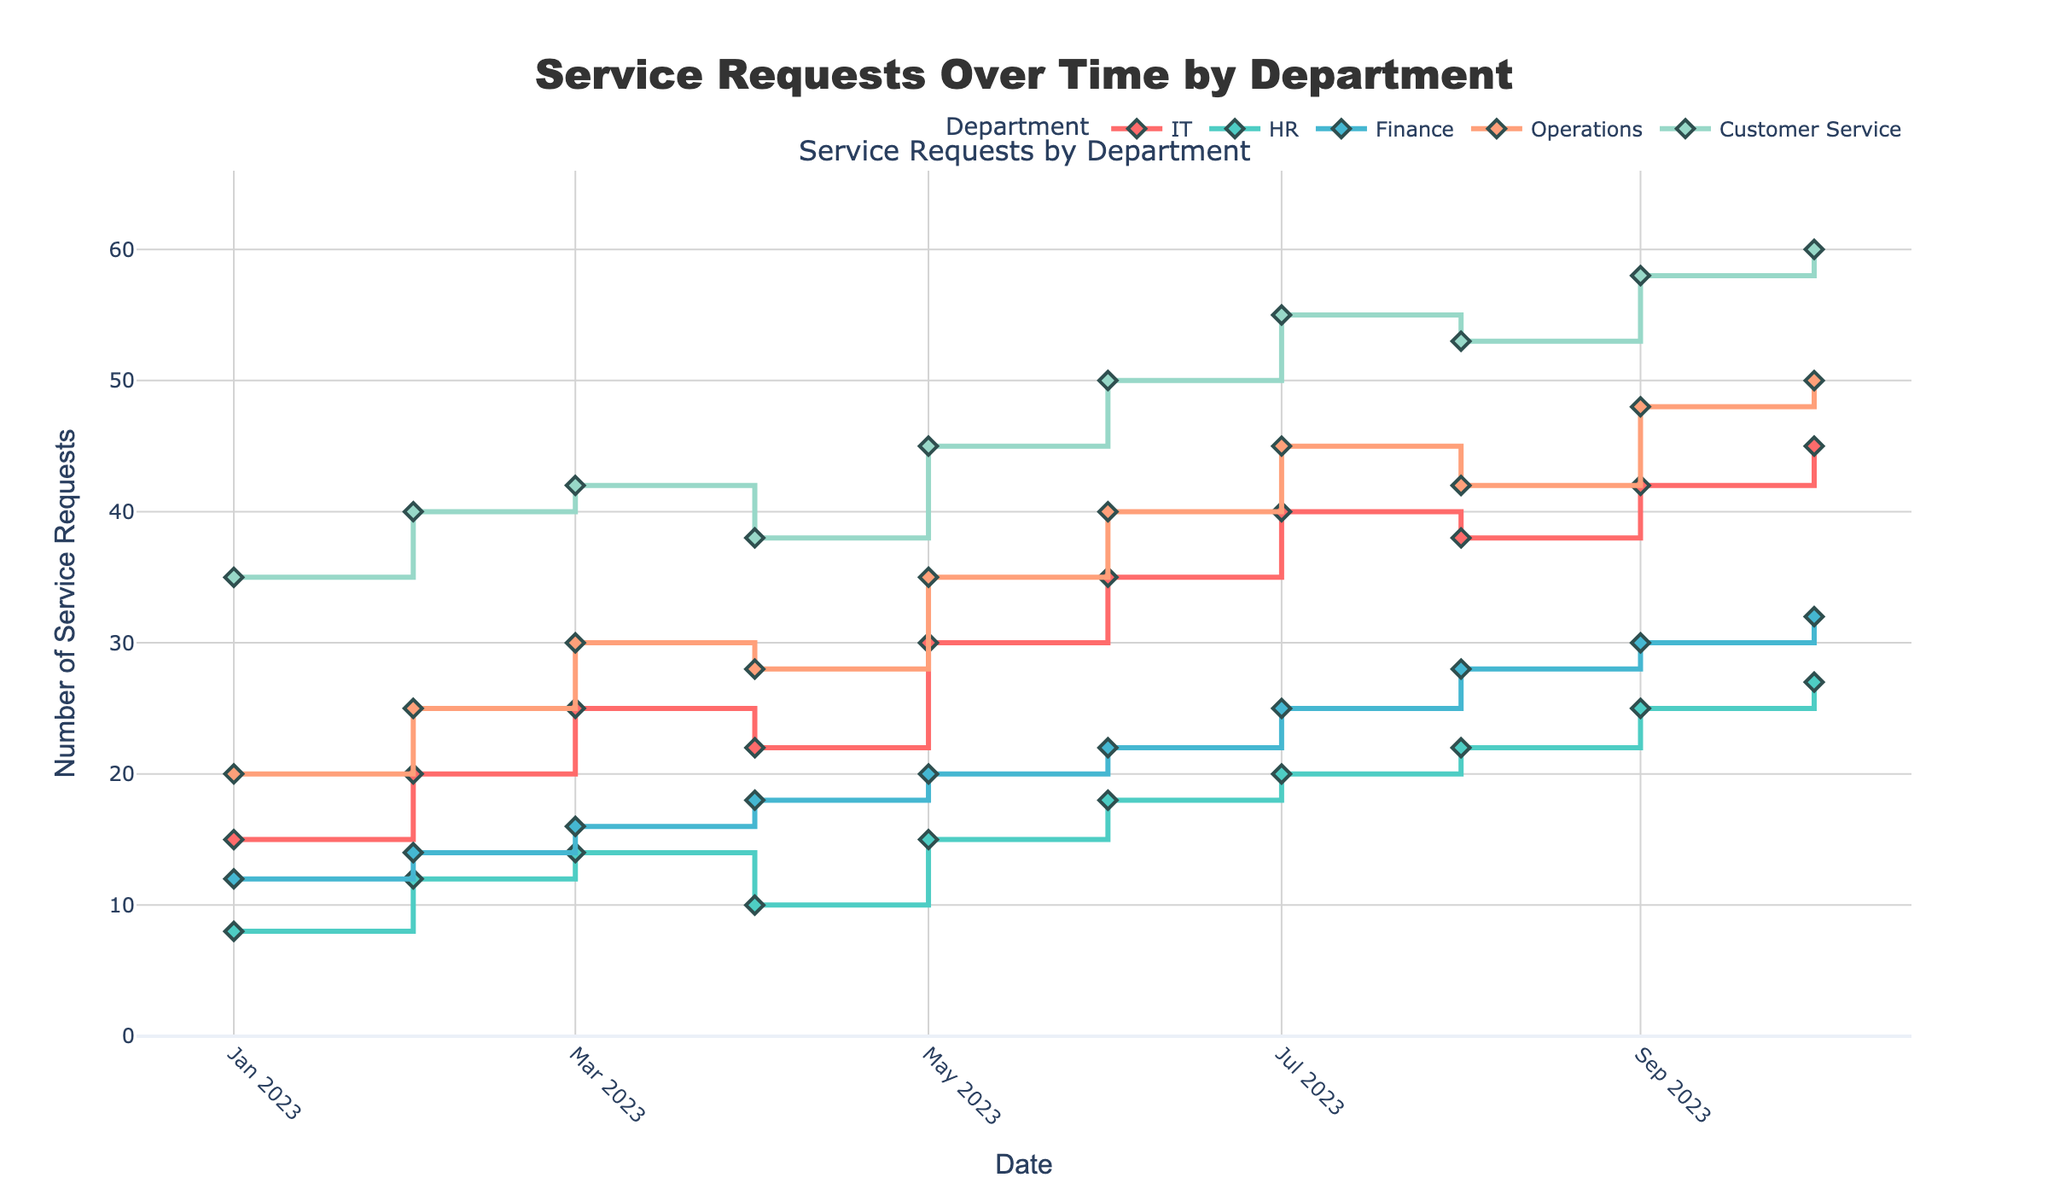what is the title of the figure? The title is positioned at the top center of the figure. It is designed to indicate what the figure represents. Analyzing the text at this location reveals the title.
Answer: Service Requests Over Time by Department which department had the highest number of service requests on July 1, 2023? Point to the date July 1, 2023, and compare the values of the various departments. Observe that Customer Service had the highest value on that date.
Answer: Customer Service how did the number of service requests in the Finance department change from January to October 2023? Trace the stair plot trend for the Finance department from January 2023 to October 2023. The points show an increase from 12 on January 1, 2023, to 32 on October 1, 2023.
Answer: From 12 to 32 what is the total number of service requests for the HR and IT departments in May 2023? Locate May 1, 2023, and note the values for HR and IT departments. Sum these values: HR (15) + IT (30) = 45.
Answer: 45 which two departments showed the most similar trends in service requests over the time period? Analyze the trends for each department and identify that Operations and Customer Service showed a continuous increase and similar pattern in their service requests.
Answer: Operations and Customer Service on which date did the IT department experience the largest increase in service requests from the previous month? Look at the IT department's plot and compare month-to-month increases. The largest increase is from June 1, 2023 (35 requests) to July 1, 2023 (40 requests), which is an increase of 5 requests.
Answer: July 1, 2023 how many times did the HR department record fewer than 20 service requests? Check each date for the HR department's values and count how many times they are below 20. The HR department recorded fewer than 20 requests 7 times (January to May and then again in August).
Answer: 7 times what are the average number of service requests for Customer Service in the first quarter of 2023? Calculate the sum of Customer Service requests in January, February, and March, and then divide by the number of months. (35 + 40 + 42) / 3 = 39.
Answer: 39 